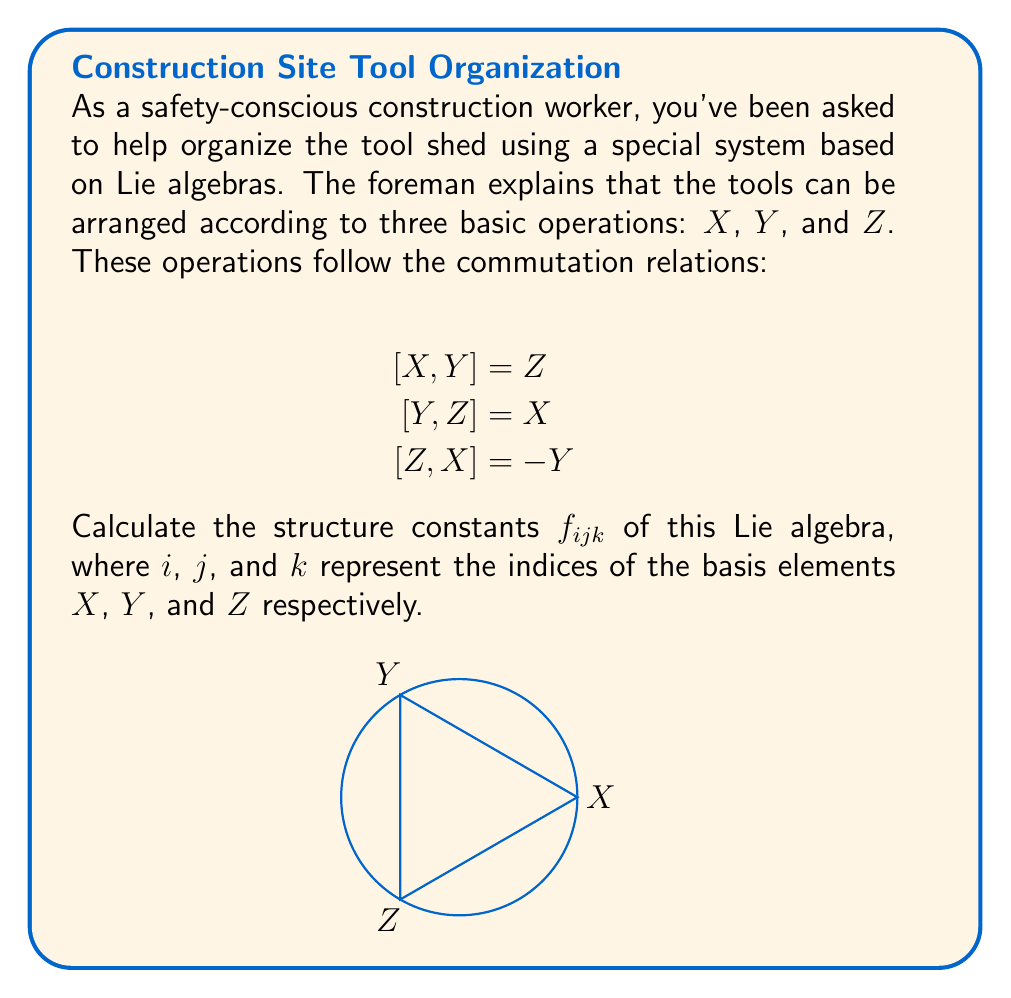Can you answer this question? Let's approach this step-by-step:

1) The structure constants $f_{ijk}$ are defined by the equation:

   $$[e_i, e_j] = \sum_k f_{ijk} e_k$$

   where $e_i$, $e_j$, and $e_k$ are basis elements of the Lie algebra.

2) In our case, $e_1 = X$, $e_2 = Y$, and $e_3 = Z$.

3) Let's consider each commutation relation:

   a) $[X, Y] = Z$ implies $f_{123} = 1$ (and $f_{213} = -1$ due to antisymmetry)
   b) $[Y, Z] = X$ implies $f_{231} = 1$ (and $f_{321} = -1$)
   c) $[Z, X] = -Y$ implies $f_{312} = -1$ (and $f_{132} = 1$)

4) All other structure constants are zero.

5) We can summarize the non-zero structure constants as:

   $f_{123} = f_{231} = 1$
   $f_{312} = -1$

   And their antisymmetric counterparts:

   $f_{213} = f_{321} = -1$
   $f_{132} = 1$

6) Note that the structure constants are antisymmetric in the first two indices:

   $f_{ijk} = -f_{jik}$

   This property is reflected in our results.
Answer: $f_{123} = f_{231} = f_{132} = 1$, $f_{213} = f_{321} = f_{312} = -1$, all others $= 0$ 